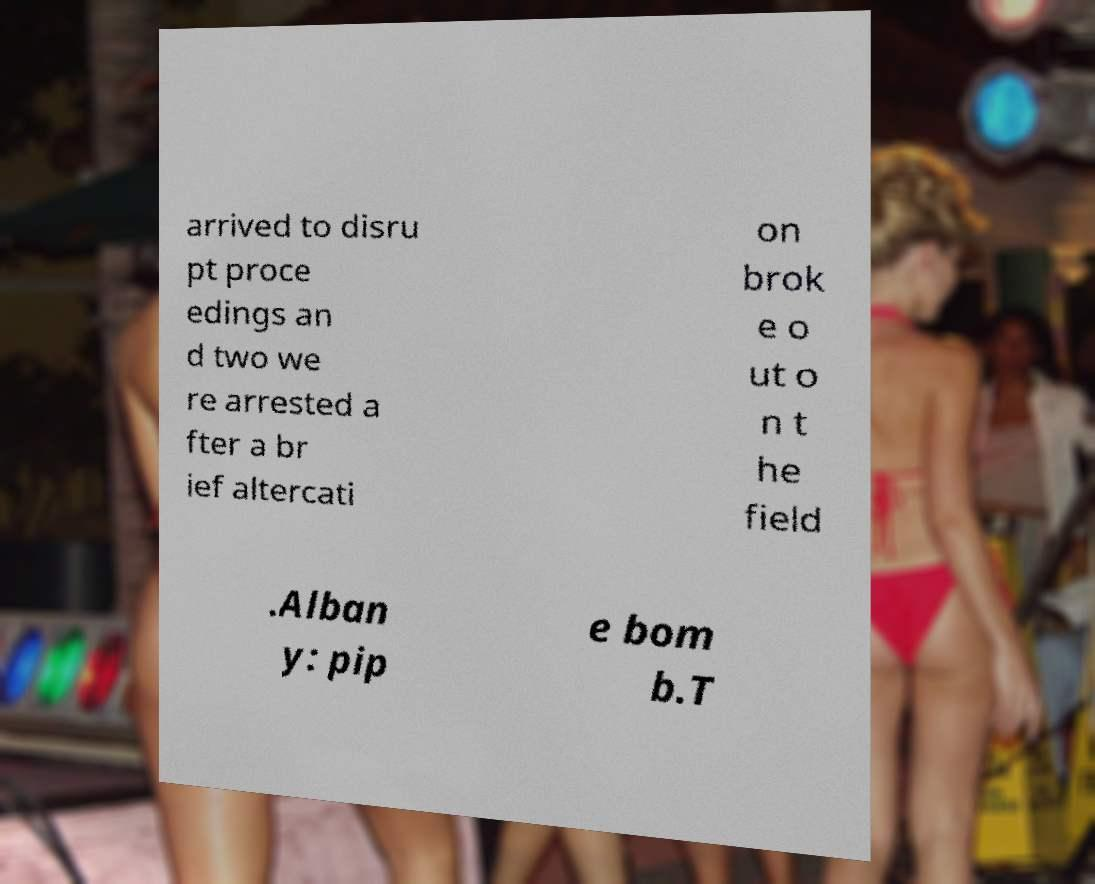Could you assist in decoding the text presented in this image and type it out clearly? arrived to disru pt proce edings an d two we re arrested a fter a br ief altercati on brok e o ut o n t he field .Alban y: pip e bom b.T 